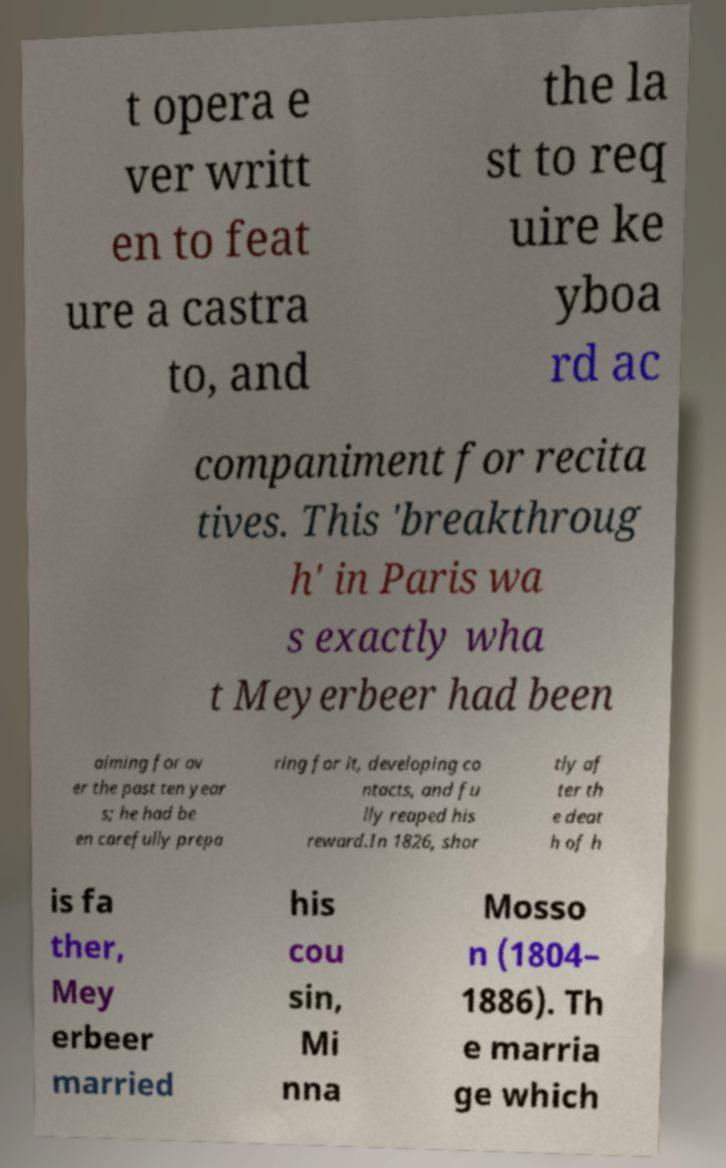For documentation purposes, I need the text within this image transcribed. Could you provide that? t opera e ver writt en to feat ure a castra to, and the la st to req uire ke yboa rd ac companiment for recita tives. This 'breakthroug h' in Paris wa s exactly wha t Meyerbeer had been aiming for ov er the past ten year s; he had be en carefully prepa ring for it, developing co ntacts, and fu lly reaped his reward.In 1826, shor tly af ter th e deat h of h is fa ther, Mey erbeer married his cou sin, Mi nna Mosso n (1804– 1886). Th e marria ge which 